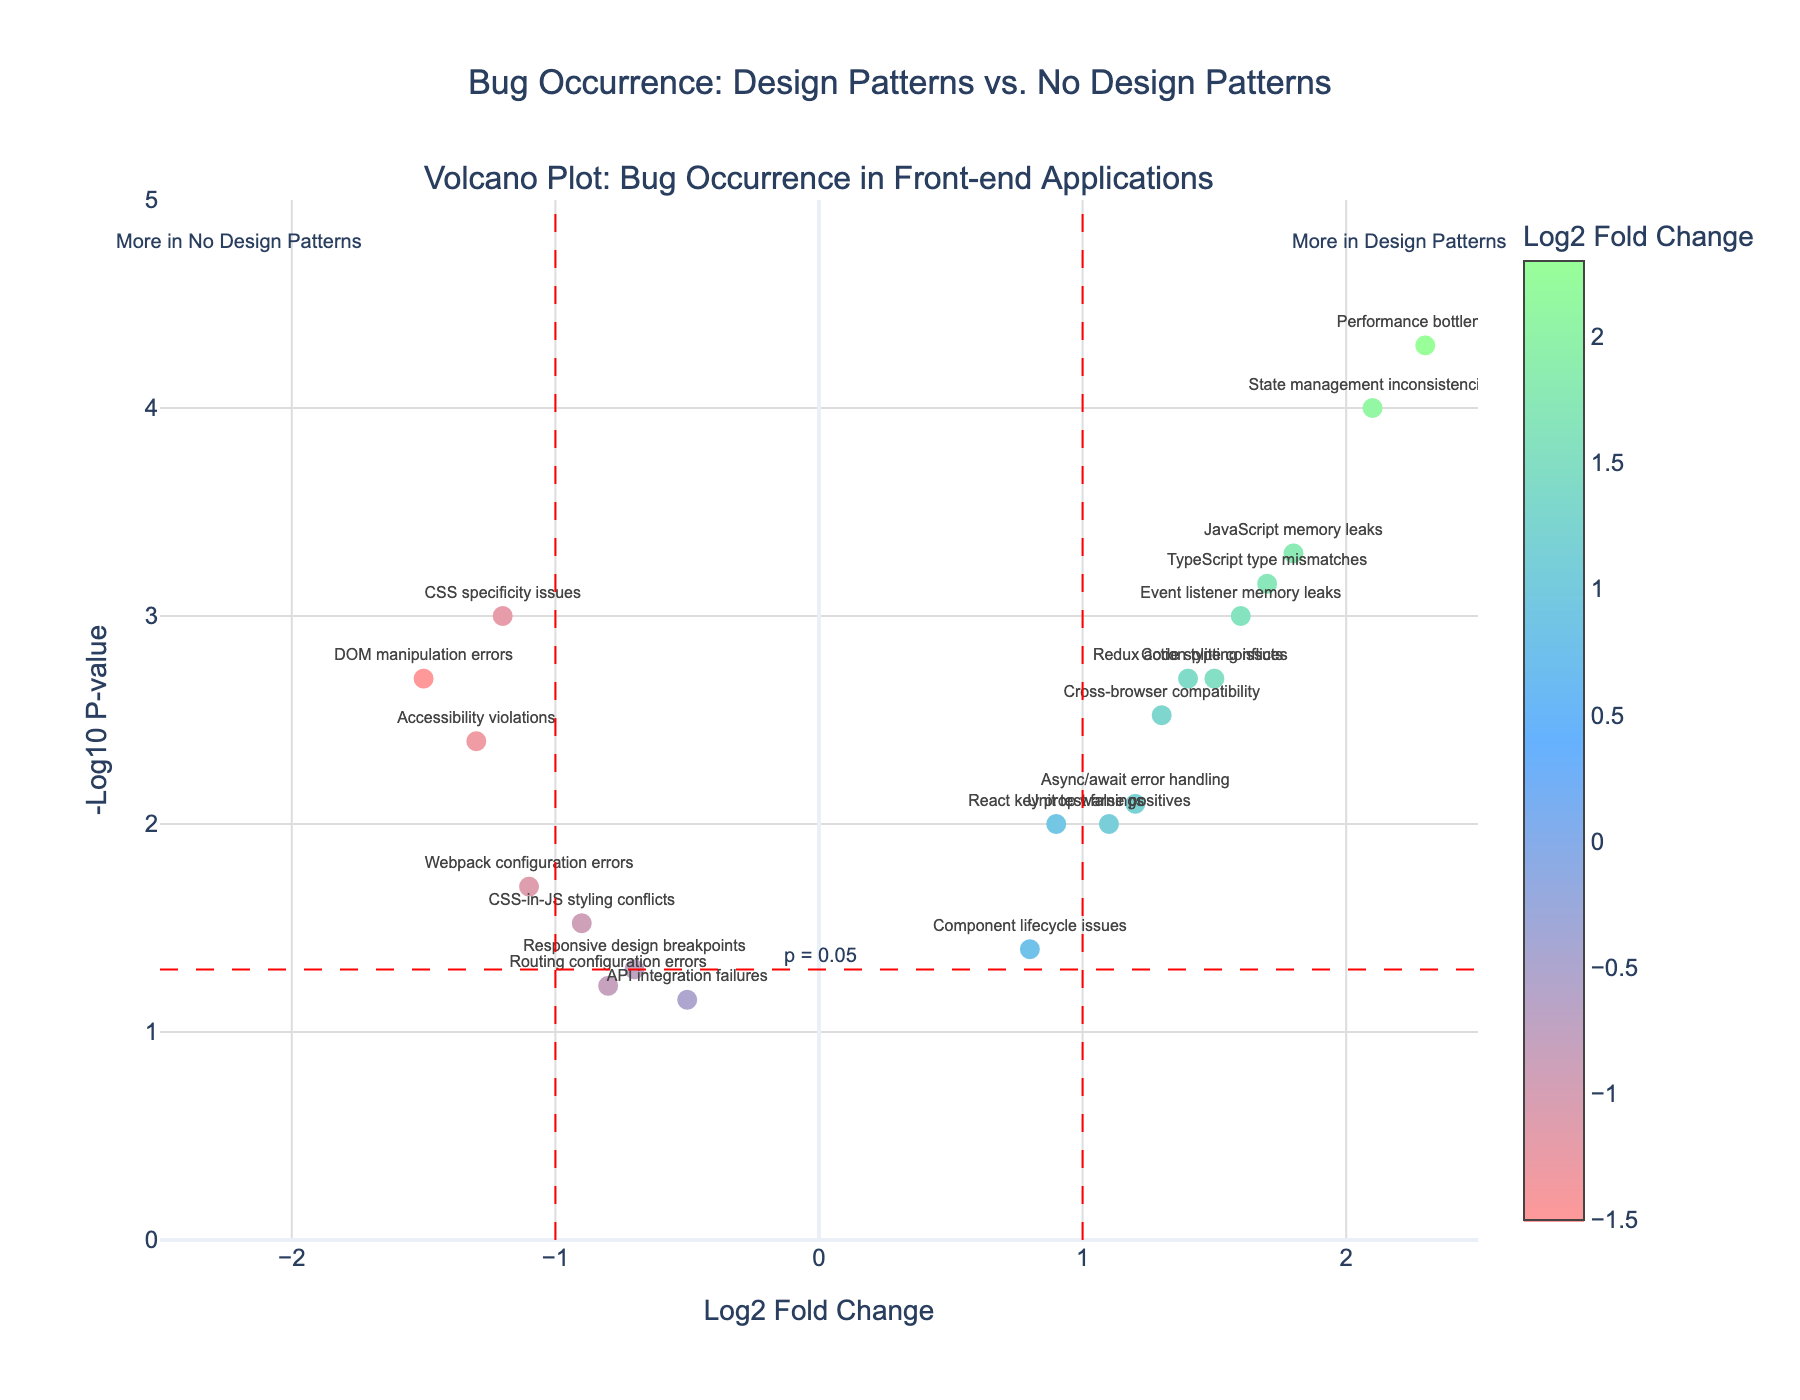What is the title of the plot? The title is displayed at the top of the plot.
Answer: Bug Occurrence: Design Patterns vs. No Design Patterns How many data points are shown in the plot? To find the number of data points, count the number of markers on the plot.
Answer: 20 Which bug type has the highest log2 fold change? Look at the x-axis values and identify the marker farthest to the right.
Answer: Performance bottlenecks Is "CSS specificity issues" more common in projects with design patterns or without? To determine this, locate the position of "CSS specificity issues" on the x-axis. Negative log2 fold change indicates it is more common in projects without design patterns.
Answer: Without Which bug type is just below the significance line for p-value (p = 0.05)? Find the red dashed horizontal line representing "-log10(p-value) = 1.3", then identify the closest marker just below this line.
Answer: Responsive design breakpoints Which bug types have a log2 fold change greater than 1 and a p-value less than 0.01? Identify the markers to the right of the vertical red line at x = 1 and above the horizontal red dashed line at y = 1.3. Multiple logical steps needed: first, find the fold change greater than 1, then identify those with p-value less than 0.01.
Answer: JavaScript memory leaks, State management inconsistencies, Event listener memory leaks, Redux action type conflicts, TypeScript type mismatches, Performance bottlenecks, Code splitting issues Do "Accessibility violations" occur more in projects with or without design patterns, and how significant is this difference? Locate "Accessibility violations" on the plot. It is at the left of x = -1, indicating it is more common without design patterns. The corresponding -log10(p-value) value should be observed for significance.
Answer: Without, significant (below p = 0.01 line) Which bug types are least likely to be impacted by using design patterns based on p-value? The least impacted would be closest to the x-axis and below the significance line at y = 1.3.
Answer: API integration failures, Routing configuration errors What is the log2 fold change and p-value for "DOM manipulation errors"? Find "DOM manipulation errors" and read the values for its x and y coordinates.
Answer: Log2 fold change: -1.5, p-value: 0.002 Which bug types are more common in projects using design patterns and also highly significant? Find markers to the right of vertical red line at x = 1 and above the horizontal red dashed line at y = 1.3. Identified as highly significant with both threshold conditions met.
Answer: State management inconsistencies, Performance bottlenecks 